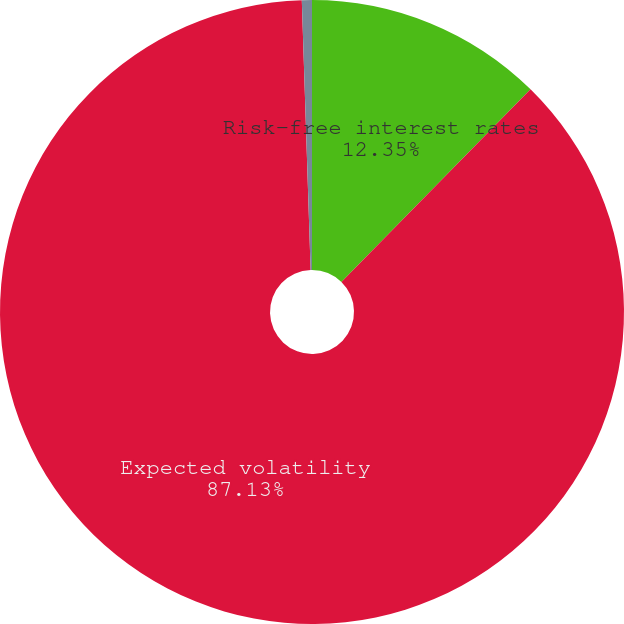<chart> <loc_0><loc_0><loc_500><loc_500><pie_chart><fcel>Risk-free interest rates<fcel>Expected volatility<fcel>Dividend yields<nl><fcel>12.35%<fcel>87.13%<fcel>0.52%<nl></chart> 